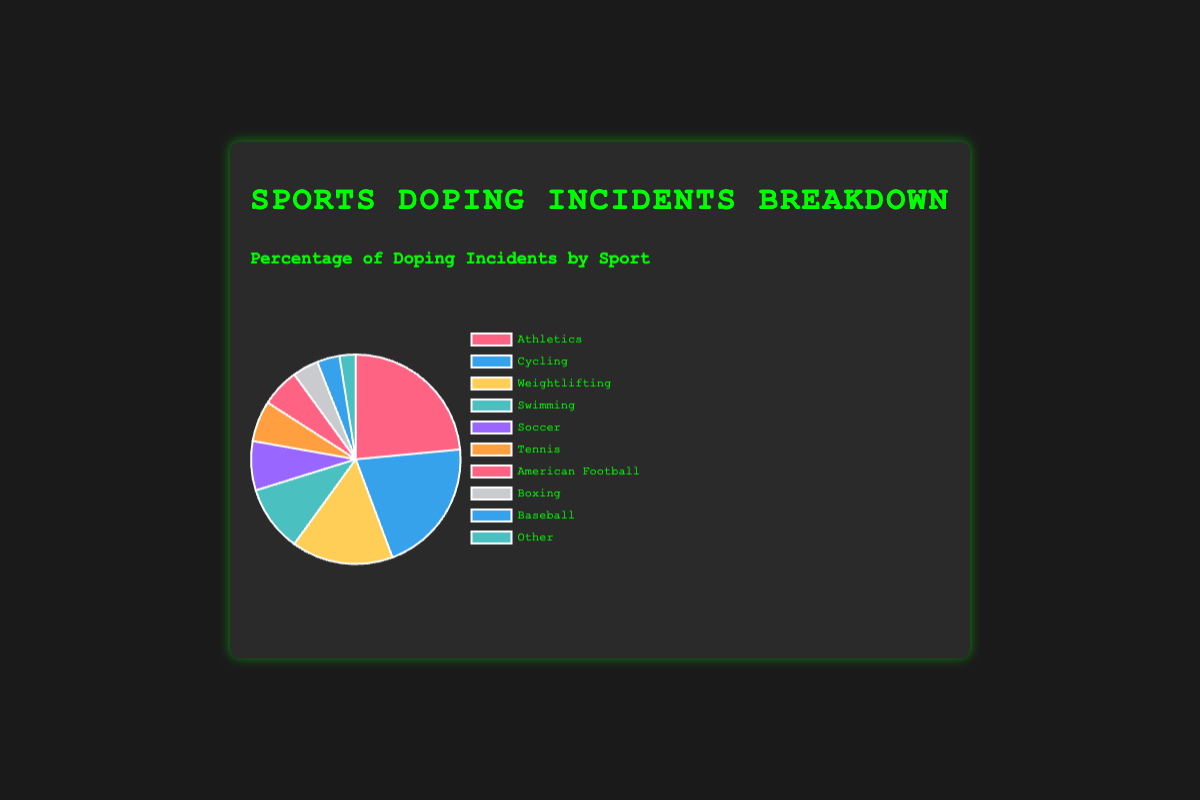Which sport has the highest percentage of doping incidents? To determine the sport with the highest percentage of doping incidents, inspect the pie chart to find the segment representing the largest proportion. The data indicates that "Athletics" holds the highest percentage at 23.5%.
Answer: Athletics What is the combined percentage of doping incidents for Cycling and Weightlifting? To find the combined percentage, add the doping incident percentages for Cycling (20.8%) and Weightlifting (15.7%). The calculation is 20.8 + 15.7 = 36.5%.
Answer: 36.5% Which sport has a lower percentage of doping incidents, Tennis or American Football? By comparing the pie chart segments for Tennis (6.3%) and American Football (5.9%), we see that American Football has a lower percentage.
Answer: American Football Is the percentage of doping incidents in Soccer higher than Swimming? Compare the doping incident percentages for Soccer (7.6%) and Swimming (10.2%). Soccer's percentage is lower, so the answer is "No".
Answer: No What is the difference in doping incident percentages between Athletics and the sport with the lowest percentage? Athletics has a doping incident percentage of 23.5%, while "Other" has the lowest at 2.5%. The difference is 23.5 - 2.5 = 21%.
Answer: 21% Which sports have doping incident percentages greater than 10%? To identify these sports, look for pie chart segments representing percentages higher than 10%. The relevant sports are Athletics (23.5%), Cycling (20.8%), and Weightlifting (15.7%), and Swimming (10.2%).
Answer: Athletics, Cycling, Weightlifting, Swimming Are there any sports in the chart with doping incident percentages below 5%? Inspect the pie chart segments for percentages less than 5%. The sports with such percentages are Boxing (4.0%), Baseball (3.5%), and Other (2.5%).
Answer: Boxing, Baseball, Other What percentage of doping incidents is accounted for by the top three sports? The top three sports in terms of doping incidents are Athletics (23.5%), Cycling (20.8%), and Weightlifting (15.7%). Adding these gives 23.5 + 20.8 + 15.7 = 60%.
Answer: 60% How much higher is the percentage of doping incidents in swimming compared to boxing? Compare the doping incident percentages for Swimming (10.2%) and Boxing (4.0%). The difference is 10.2 - 4.0 = 6.2%.
Answer: 6.2% What would be the percentage of doping incidents for "Other" sports if Baseball was removed from the list? Removing Baseball (3.5%) means the total percentage reduces to 100% - 3.5% = 96.5%. The "Other" category currently at 2.5% would then become 2.5% of 96.5% due to the recalibration of the total subset. This can be approximately recalculated using the proportion:
(100% / (100% - 3.5%)) * 2.5% = ~2.59%.
Answer: ~2.59% 